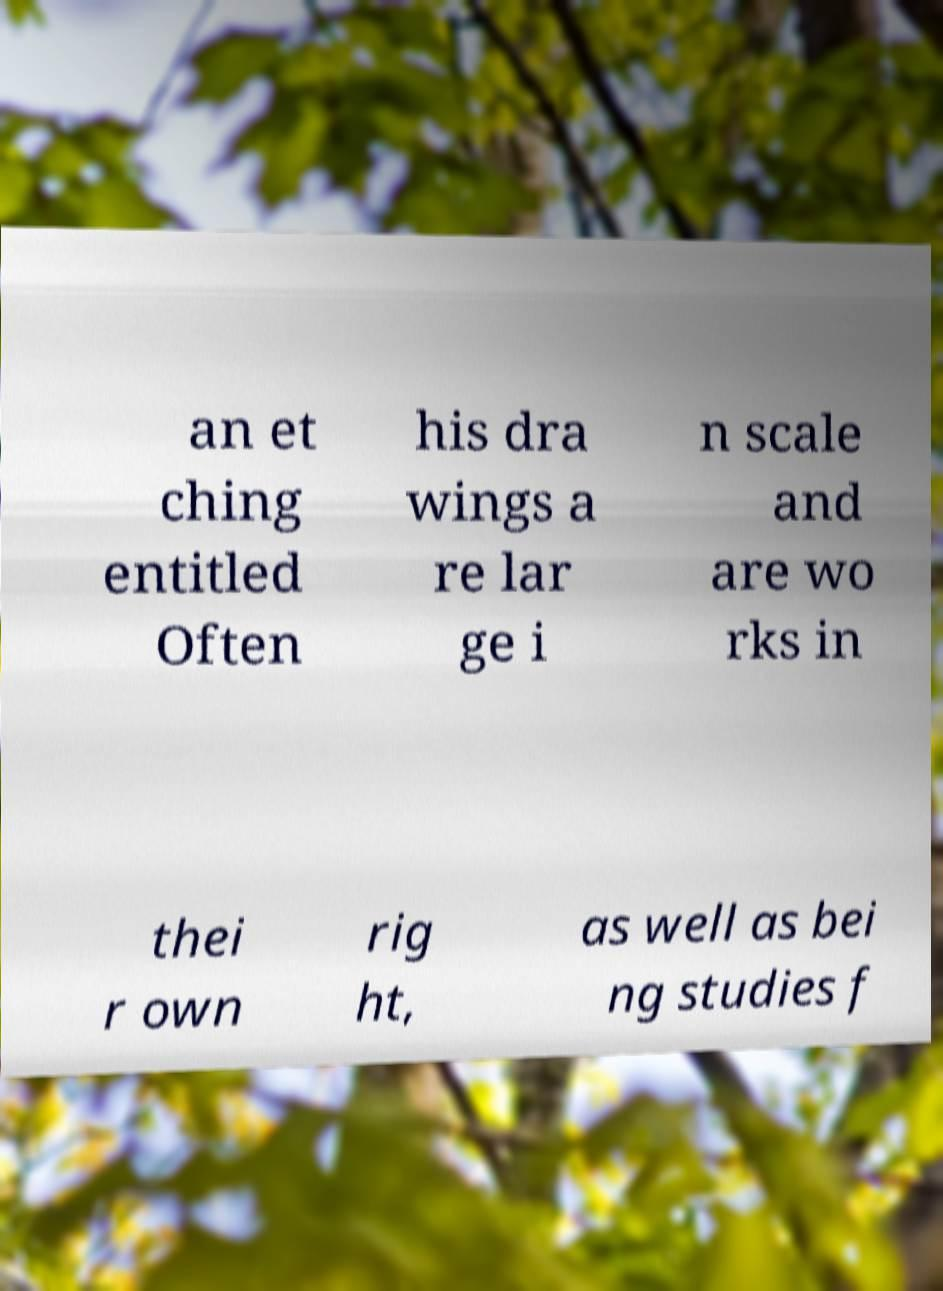Could you assist in decoding the text presented in this image and type it out clearly? an et ching entitled Often his dra wings a re lar ge i n scale and are wo rks in thei r own rig ht, as well as bei ng studies f 